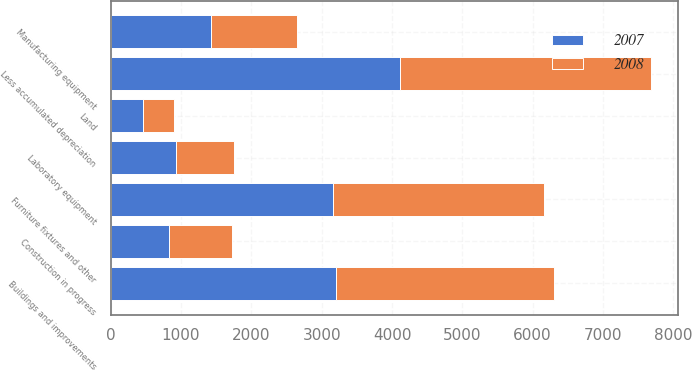Convert chart. <chart><loc_0><loc_0><loc_500><loc_500><stacked_bar_chart><ecel><fcel>Land<fcel>Buildings and improvements<fcel>Manufacturing equipment<fcel>Laboratory equipment<fcel>Furniture fixtures and other<fcel>Construction in progress<fcel>Less accumulated depreciation<nl><fcel>2007<fcel>456<fcel>3205<fcel>1431<fcel>923<fcel>3154<fcel>826<fcel>4116<nl><fcel>2008<fcel>451<fcel>3102<fcel>1221<fcel>831<fcel>3003<fcel>893<fcel>3560<nl></chart> 